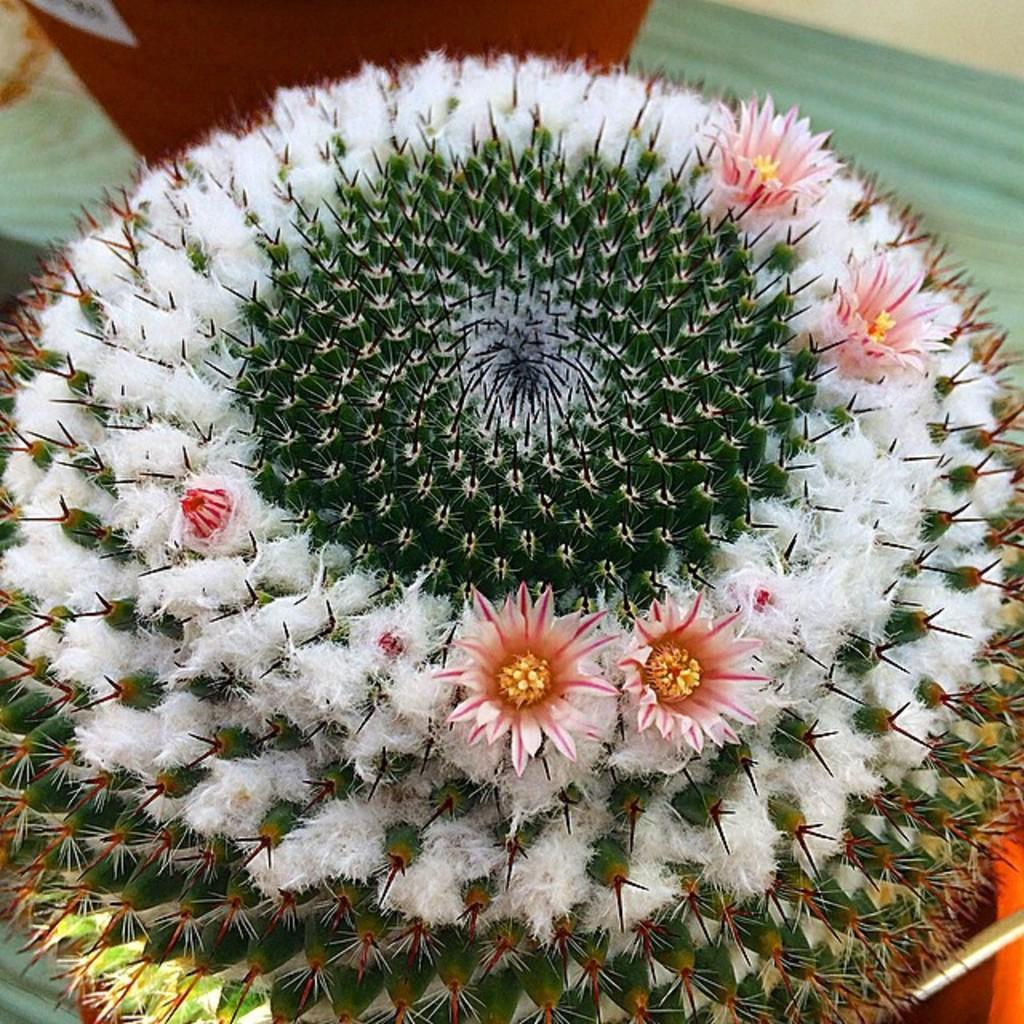In one or two sentences, can you explain what this image depicts? In this picture it looks like a kind of plant with flowers and thorns around it. 